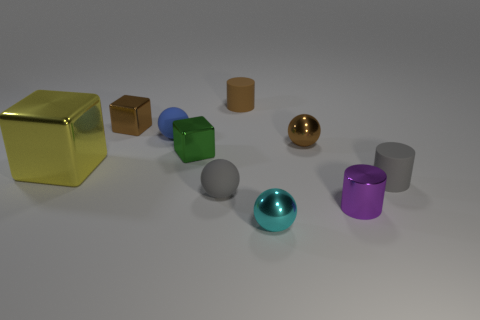There is a small gray rubber object that is to the right of the small cyan object; what is its shape?
Ensure brevity in your answer.  Cylinder. How many gray matte spheres are there?
Keep it short and to the point. 1. What color is the large block that is the same material as the green object?
Keep it short and to the point. Yellow. How many small things are either yellow shiny things or green cylinders?
Offer a terse response. 0. How many big shiny things are in front of the purple metal object?
Give a very brief answer. 0. There is another small shiny thing that is the same shape as the small cyan metal thing; what color is it?
Offer a terse response. Brown. How many metallic things are green blocks or brown balls?
Offer a terse response. 2. Is there a cyan metal thing that is to the left of the tiny brown shiny thing that is on the right side of the rubber ball in front of the small blue thing?
Give a very brief answer. Yes. What color is the shiny cylinder?
Offer a terse response. Purple. Do the tiny brown thing that is left of the small green block and the green object have the same shape?
Your answer should be compact. Yes. 